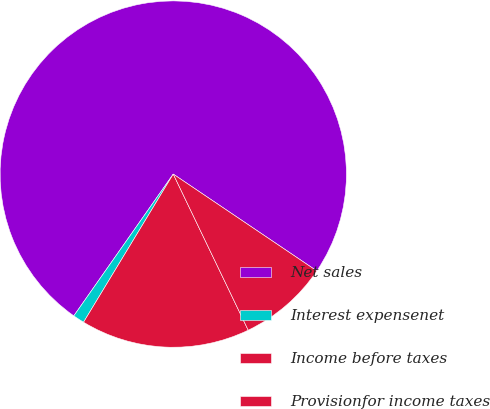Convert chart. <chart><loc_0><loc_0><loc_500><loc_500><pie_chart><fcel>Net sales<fcel>Interest expensenet<fcel>Income before taxes<fcel>Provisionfor income taxes<nl><fcel>74.71%<fcel>1.07%<fcel>15.79%<fcel>8.43%<nl></chart> 